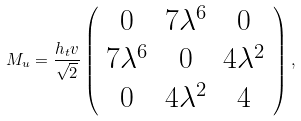<formula> <loc_0><loc_0><loc_500><loc_500>M _ { u } = \frac { h _ { t } v } { \sqrt { 2 } } \left ( \begin{array} { c c c } 0 & 7 \lambda ^ { 6 } & 0 \\ 7 \lambda ^ { 6 } & 0 & 4 \lambda ^ { 2 } \\ 0 & 4 \lambda ^ { 2 } & 4 \end{array} \right ) ,</formula> 